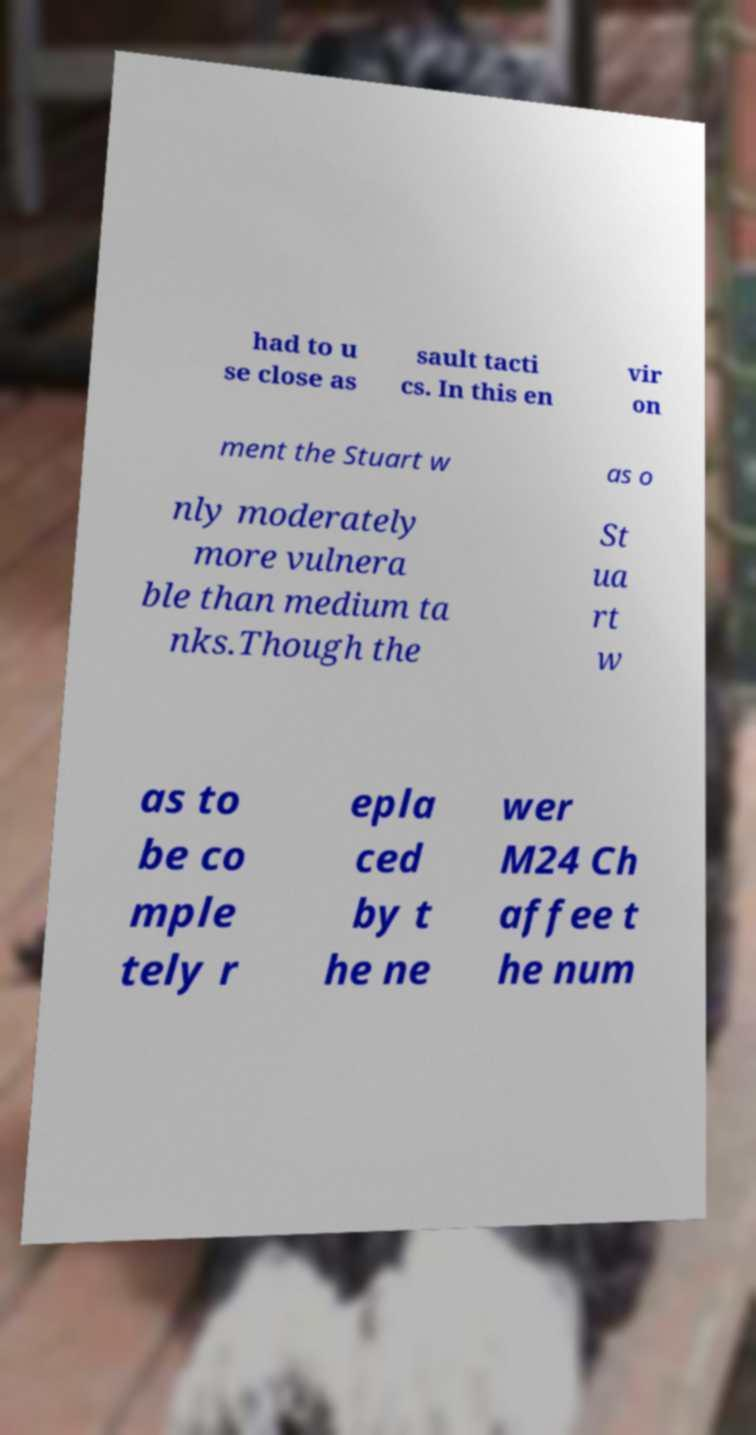There's text embedded in this image that I need extracted. Can you transcribe it verbatim? had to u se close as sault tacti cs. In this en vir on ment the Stuart w as o nly moderately more vulnera ble than medium ta nks.Though the St ua rt w as to be co mple tely r epla ced by t he ne wer M24 Ch affee t he num 